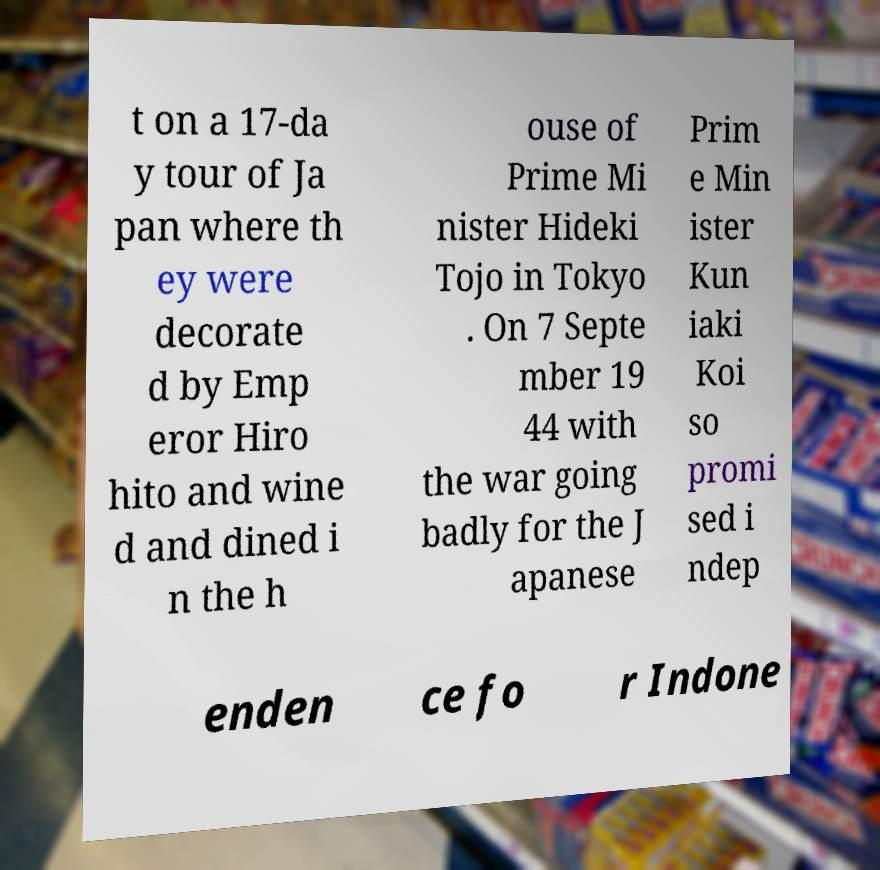Please read and relay the text visible in this image. What does it say? t on a 17-da y tour of Ja pan where th ey were decorate d by Emp eror Hiro hito and wine d and dined i n the h ouse of Prime Mi nister Hideki Tojo in Tokyo . On 7 Septe mber 19 44 with the war going badly for the J apanese Prim e Min ister Kun iaki Koi so promi sed i ndep enden ce fo r Indone 